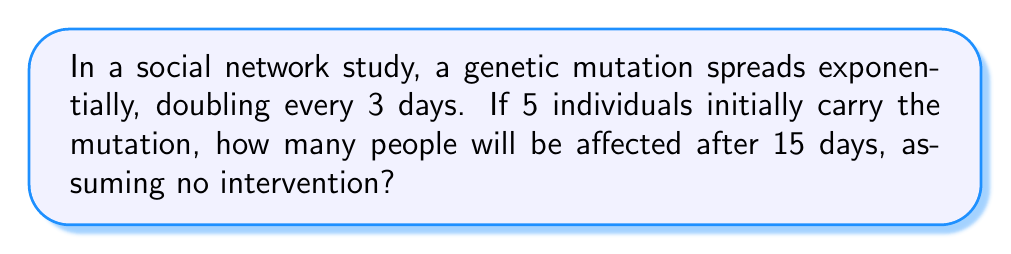Can you solve this math problem? To solve this problem, we need to follow these steps:

1. Identify the initial number of individuals: $N_0 = 5$

2. Determine the growth factor:
   The population doubles every 3 days, so the growth factor per 3-day period is 2.

3. Calculate the number of 3-day periods in 15 days:
   $\text{Number of periods} = \frac{15 \text{ days}}{3 \text{ days/period}} = 5 \text{ periods}$

4. Use the exponential growth formula:
   $N(t) = N_0 \cdot 2^t$
   Where:
   $N(t)$ is the number of affected individuals after time $t$
   $N_0$ is the initial number of individuals
   $t$ is the number of 3-day periods

5. Plug in the values:
   $N(5) = 5 \cdot 2^5$

6. Calculate the result:
   $N(5) = 5 \cdot 32 = 160$

Therefore, after 15 days, 160 people will be affected by the genetic mutation.
Answer: 160 people 